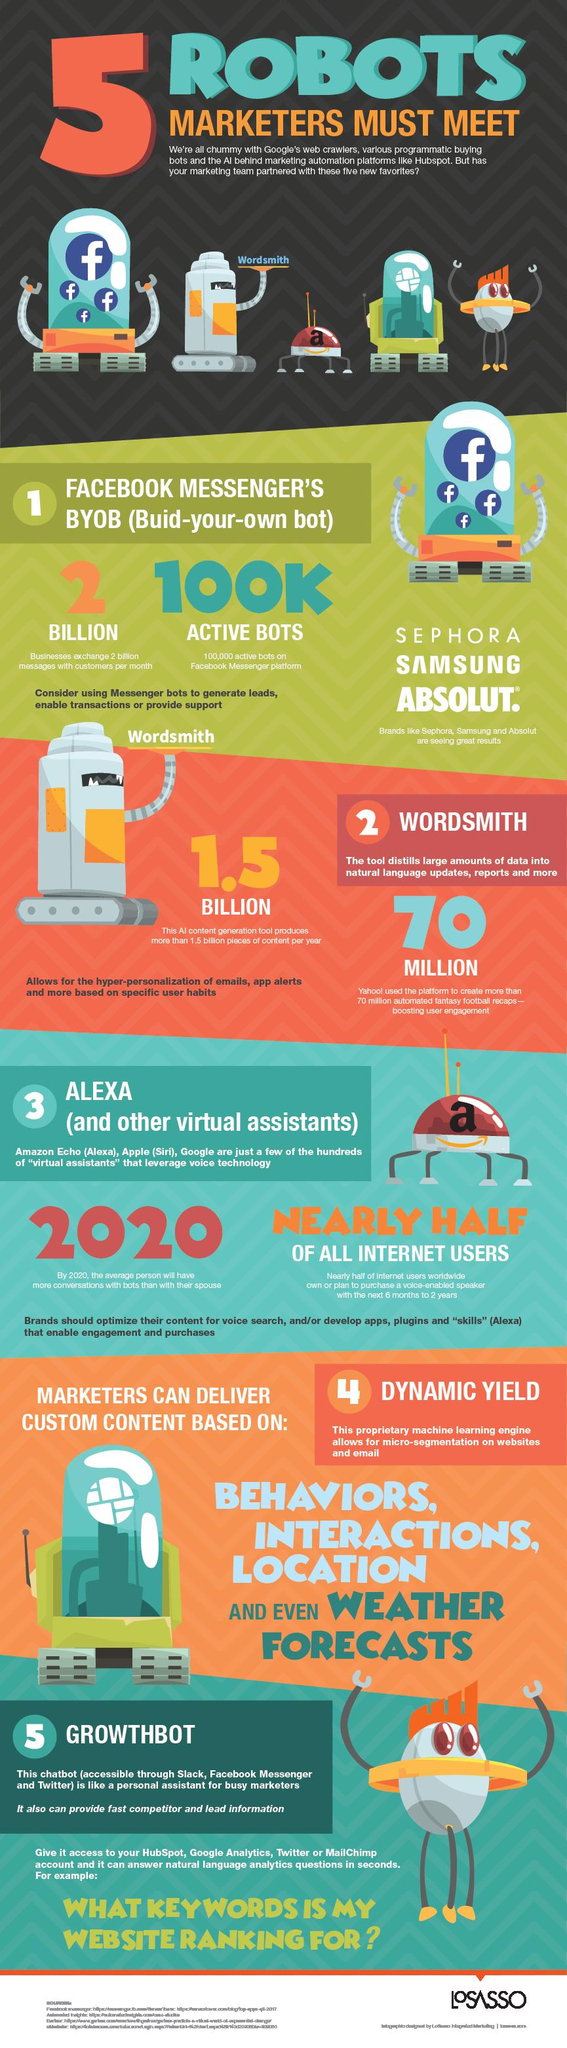Specify some key components in this picture. It has been determined that the color of the eye of GrowthBot is red. Marketers can deliver custom content based on a variety of factors, including behaviors, interactions, location, and even weather forecasts. Alexa is a virtual assistant that provides various services to users. Yahoo was the online platform that used wordsmith. Sephora, Samsung, and Absolut are companies that are utilizing Facebook Messenger's BYOB feature. 